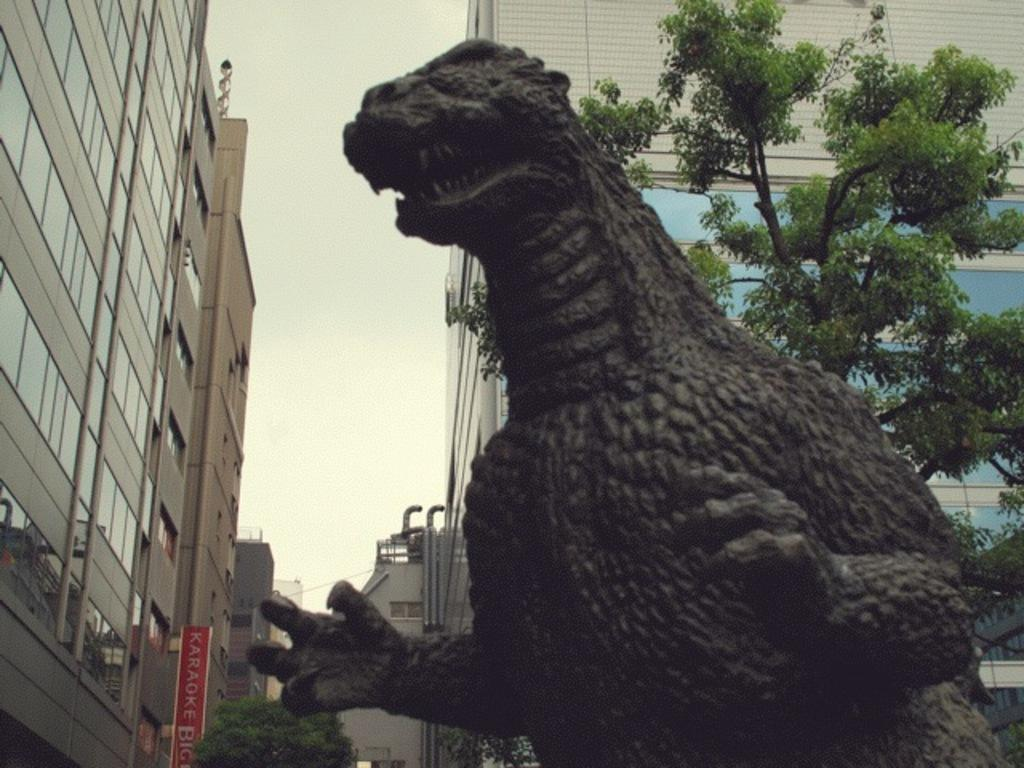What type of dinosaur statue can be seen in the image? There is a black color dinosaur statue in the image. What can be seen in the background of the image? Trees and buildings are present in the background of the image. What type of yak can be seen grazing near the dinosaur statue in the image? There is no yak present in the image; it only features a black color dinosaur statue and the background with trees and buildings. 